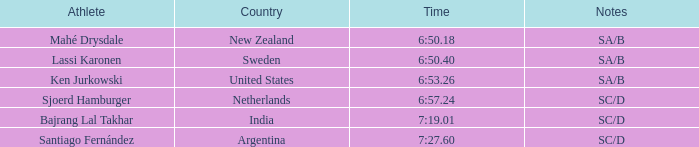What is the supreme standing for the team that completed a time of 6:5 2.0. 